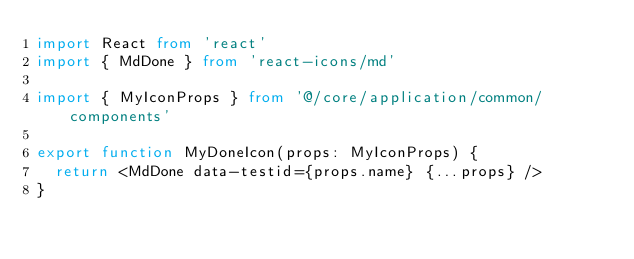Convert code to text. <code><loc_0><loc_0><loc_500><loc_500><_TypeScript_>import React from 'react'
import { MdDone } from 'react-icons/md'

import { MyIconProps } from '@/core/application/common/components'

export function MyDoneIcon(props: MyIconProps) {
  return <MdDone data-testid={props.name} {...props} />
}
</code> 